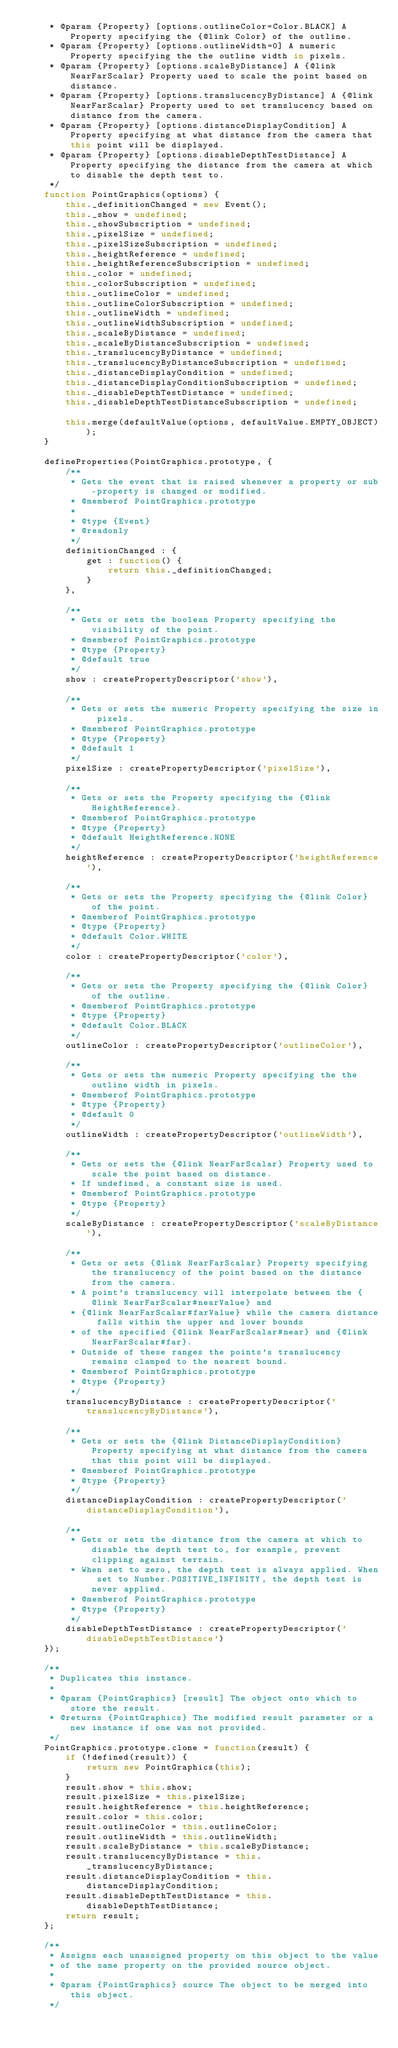Convert code to text. <code><loc_0><loc_0><loc_500><loc_500><_JavaScript_>     * @param {Property} [options.outlineColor=Color.BLACK] A Property specifying the {@link Color} of the outline.
     * @param {Property} [options.outlineWidth=0] A numeric Property specifying the the outline width in pixels.
     * @param {Property} [options.scaleByDistance] A {@link NearFarScalar} Property used to scale the point based on distance.
     * @param {Property} [options.translucencyByDistance] A {@link NearFarScalar} Property used to set translucency based on distance from the camera.
     * @param {Property} [options.distanceDisplayCondition] A Property specifying at what distance from the camera that this point will be displayed.
     * @param {Property} [options.disableDepthTestDistance] A Property specifying the distance from the camera at which to disable the depth test to.
     */
    function PointGraphics(options) {
        this._definitionChanged = new Event();
        this._show = undefined;
        this._showSubscription = undefined;
        this._pixelSize = undefined;
        this._pixelSizeSubscription = undefined;
        this._heightReference = undefined;
        this._heightReferenceSubscription = undefined;
        this._color = undefined;
        this._colorSubscription = undefined;
        this._outlineColor = undefined;
        this._outlineColorSubscription = undefined;
        this._outlineWidth = undefined;
        this._outlineWidthSubscription = undefined;
        this._scaleByDistance = undefined;
        this._scaleByDistanceSubscription = undefined;
        this._translucencyByDistance = undefined;
        this._translucencyByDistanceSubscription = undefined;
        this._distanceDisplayCondition = undefined;
        this._distanceDisplayConditionSubscription = undefined;
        this._disableDepthTestDistance = undefined;
        this._disableDepthTestDistanceSubscription = undefined;

        this.merge(defaultValue(options, defaultValue.EMPTY_OBJECT));
    }

    defineProperties(PointGraphics.prototype, {
        /**
         * Gets the event that is raised whenever a property or sub-property is changed or modified.
         * @memberof PointGraphics.prototype
         *
         * @type {Event}
         * @readonly
         */
        definitionChanged : {
            get : function() {
                return this._definitionChanged;
            }
        },

        /**
         * Gets or sets the boolean Property specifying the visibility of the point.
         * @memberof PointGraphics.prototype
         * @type {Property}
         * @default true
         */
        show : createPropertyDescriptor('show'),

        /**
         * Gets or sets the numeric Property specifying the size in pixels.
         * @memberof PointGraphics.prototype
         * @type {Property}
         * @default 1
         */
        pixelSize : createPropertyDescriptor('pixelSize'),

        /**
         * Gets or sets the Property specifying the {@link HeightReference}.
         * @memberof PointGraphics.prototype
         * @type {Property}
         * @default HeightReference.NONE
         */
        heightReference : createPropertyDescriptor('heightReference'),

        /**
         * Gets or sets the Property specifying the {@link Color} of the point.
         * @memberof PointGraphics.prototype
         * @type {Property}
         * @default Color.WHITE
         */
        color : createPropertyDescriptor('color'),

        /**
         * Gets or sets the Property specifying the {@link Color} of the outline.
         * @memberof PointGraphics.prototype
         * @type {Property}
         * @default Color.BLACK
         */
        outlineColor : createPropertyDescriptor('outlineColor'),

        /**
         * Gets or sets the numeric Property specifying the the outline width in pixels.
         * @memberof PointGraphics.prototype
         * @type {Property}
         * @default 0
         */
        outlineWidth : createPropertyDescriptor('outlineWidth'),

        /**
         * Gets or sets the {@link NearFarScalar} Property used to scale the point based on distance.
         * If undefined, a constant size is used.
         * @memberof PointGraphics.prototype
         * @type {Property}
         */
        scaleByDistance : createPropertyDescriptor('scaleByDistance'),

        /**
         * Gets or sets {@link NearFarScalar} Property specifying the translucency of the point based on the distance from the camera.
         * A point's translucency will interpolate between the {@link NearFarScalar#nearValue} and
         * {@link NearFarScalar#farValue} while the camera distance falls within the upper and lower bounds
         * of the specified {@link NearFarScalar#near} and {@link NearFarScalar#far}.
         * Outside of these ranges the points's translucency remains clamped to the nearest bound.
         * @memberof PointGraphics.prototype
         * @type {Property}
         */
        translucencyByDistance : createPropertyDescriptor('translucencyByDistance'),

        /**
         * Gets or sets the {@link DistanceDisplayCondition} Property specifying at what distance from the camera that this point will be displayed.
         * @memberof PointGraphics.prototype
         * @type {Property}
         */
        distanceDisplayCondition : createPropertyDescriptor('distanceDisplayCondition'),

        /**
         * Gets or sets the distance from the camera at which to disable the depth test to, for example, prevent clipping against terrain.
         * When set to zero, the depth test is always applied. When set to Number.POSITIVE_INFINITY, the depth test is never applied.
         * @memberof PointGraphics.prototype
         * @type {Property}
         */
        disableDepthTestDistance : createPropertyDescriptor('disableDepthTestDistance')
    });

    /**
     * Duplicates this instance.
     *
     * @param {PointGraphics} [result] The object onto which to store the result.
     * @returns {PointGraphics} The modified result parameter or a new instance if one was not provided.
     */
    PointGraphics.prototype.clone = function(result) {
        if (!defined(result)) {
            return new PointGraphics(this);
        }
        result.show = this.show;
        result.pixelSize = this.pixelSize;
        result.heightReference = this.heightReference;
        result.color = this.color;
        result.outlineColor = this.outlineColor;
        result.outlineWidth = this.outlineWidth;
        result.scaleByDistance = this.scaleByDistance;
        result.translucencyByDistance = this._translucencyByDistance;
        result.distanceDisplayCondition = this.distanceDisplayCondition;
        result.disableDepthTestDistance = this.disableDepthTestDistance;
        return result;
    };

    /**
     * Assigns each unassigned property on this object to the value
     * of the same property on the provided source object.
     *
     * @param {PointGraphics} source The object to be merged into this object.
     */</code> 